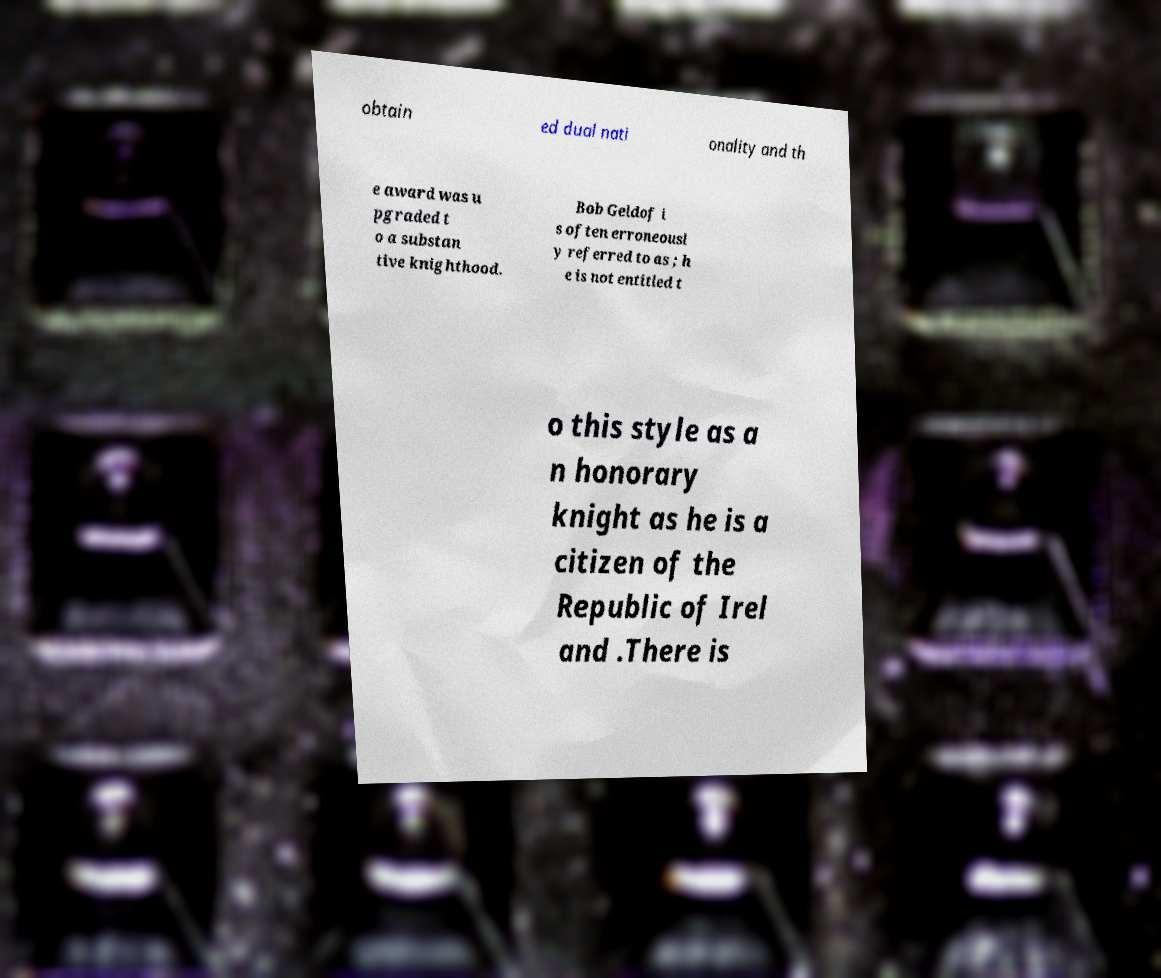Can you read and provide the text displayed in the image?This photo seems to have some interesting text. Can you extract and type it out for me? obtain ed dual nati onality and th e award was u pgraded t o a substan tive knighthood. Bob Geldof i s often erroneousl y referred to as ; h e is not entitled t o this style as a n honorary knight as he is a citizen of the Republic of Irel and .There is 